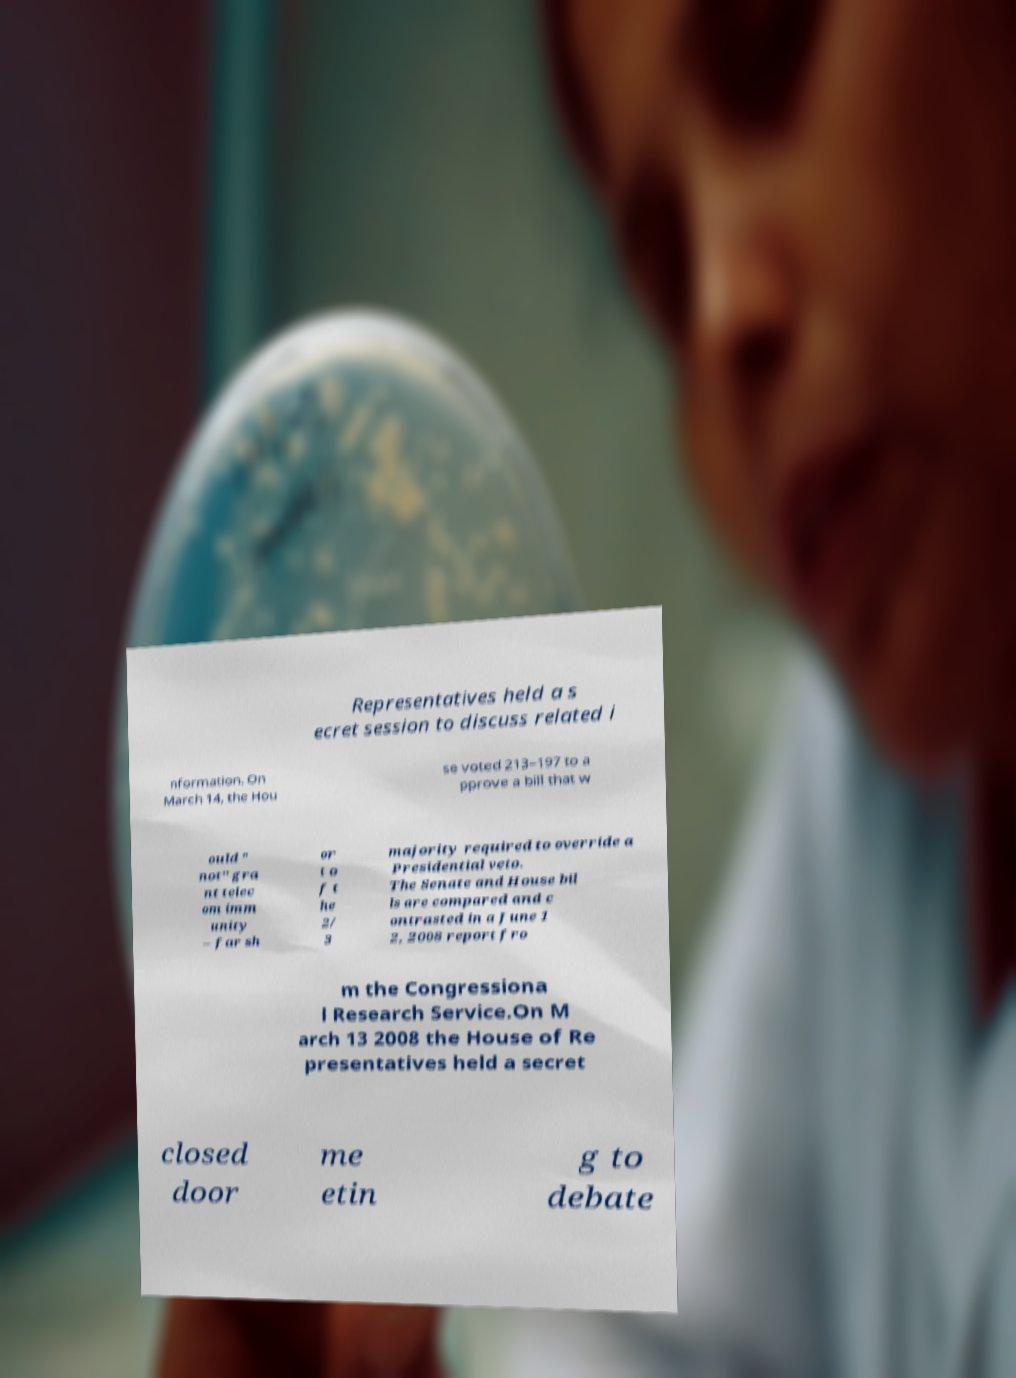What messages or text are displayed in this image? I need them in a readable, typed format. Representatives held a s ecret session to discuss related i nformation. On March 14, the Hou se voted 213–197 to a pprove a bill that w ould " not" gra nt telec om imm unity – far sh or t o f t he 2/ 3 majority required to override a Presidential veto. The Senate and House bil ls are compared and c ontrasted in a June 1 2, 2008 report fro m the Congressiona l Research Service.On M arch 13 2008 the House of Re presentatives held a secret closed door me etin g to debate 